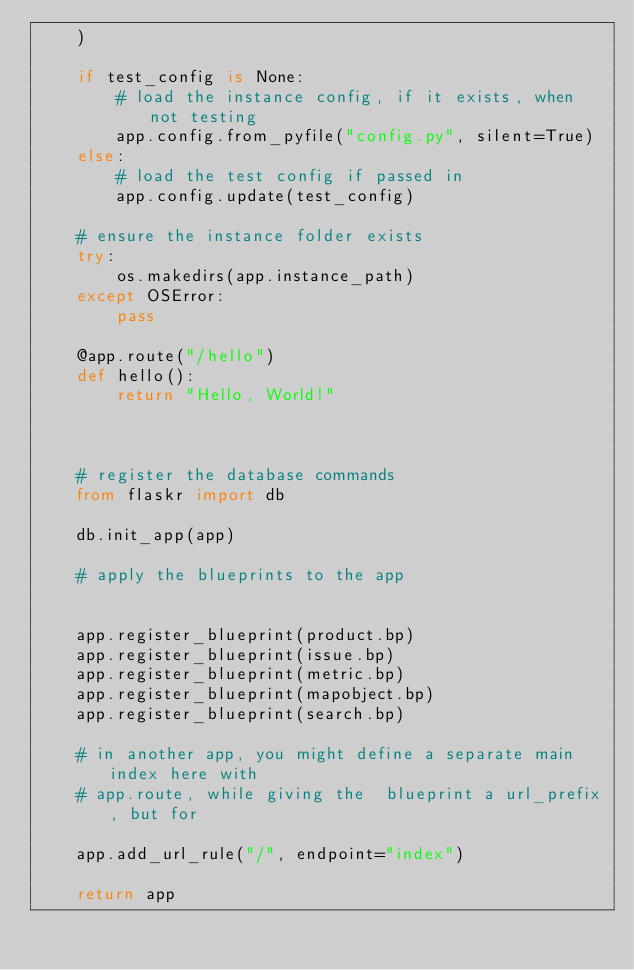<code> <loc_0><loc_0><loc_500><loc_500><_Python_>    )

    if test_config is None:
        # load the instance config, if it exists, when not testing
        app.config.from_pyfile("config.py", silent=True)
    else:
        # load the test config if passed in
        app.config.update(test_config)

    # ensure the instance folder exists
    try:
        os.makedirs(app.instance_path)
    except OSError:
        pass

    @app.route("/hello")
    def hello():
        return "Hello, World!"

    

    # register the database commands
    from flaskr import db

    db.init_app(app)

    # apply the blueprints to the app   

    
    app.register_blueprint(product.bp)
    app.register_blueprint(issue.bp)
    app.register_blueprint(metric.bp)
    app.register_blueprint(mapobject.bp)
    app.register_blueprint(search.bp)

    # in another app, you might define a separate main index here with
    # app.route, while giving the  blueprint a url_prefix, but for
    
    app.add_url_rule("/", endpoint="index")

    return app
</code> 